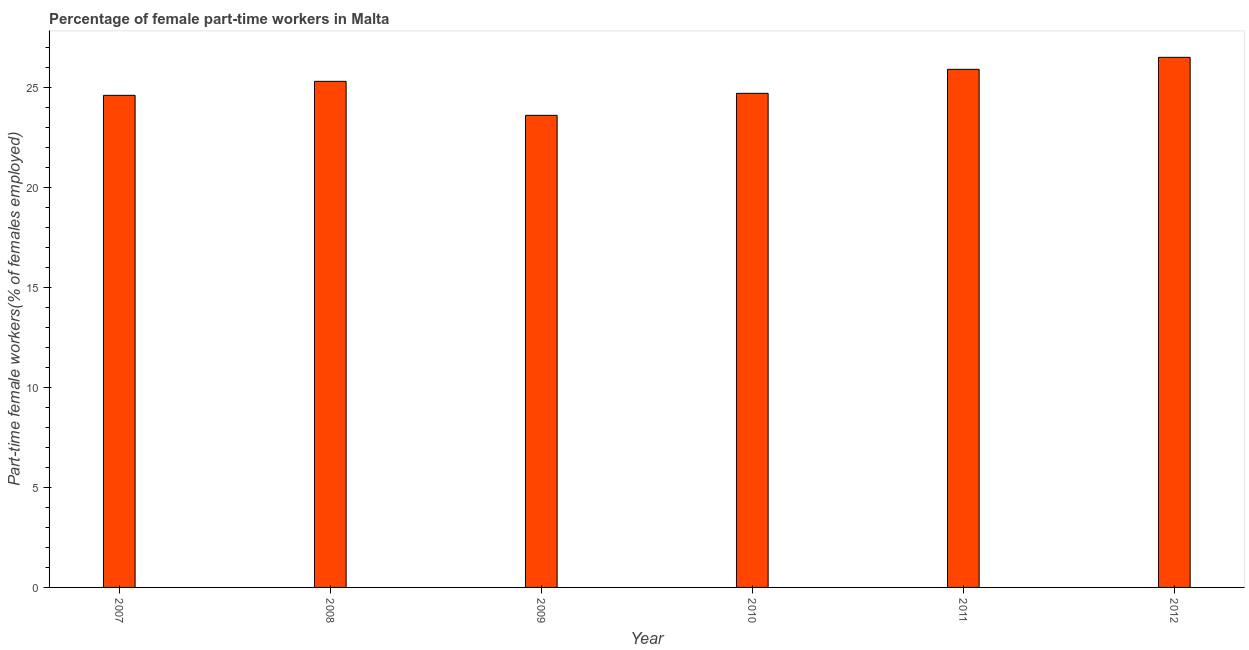What is the title of the graph?
Give a very brief answer. Percentage of female part-time workers in Malta. What is the label or title of the X-axis?
Your answer should be very brief. Year. What is the label or title of the Y-axis?
Keep it short and to the point. Part-time female workers(% of females employed). What is the percentage of part-time female workers in 2009?
Keep it short and to the point. 23.6. Across all years, what is the minimum percentage of part-time female workers?
Your response must be concise. 23.6. In which year was the percentage of part-time female workers maximum?
Make the answer very short. 2012. In which year was the percentage of part-time female workers minimum?
Your answer should be compact. 2009. What is the sum of the percentage of part-time female workers?
Provide a succinct answer. 150.6. What is the average percentage of part-time female workers per year?
Offer a very short reply. 25.1. Do a majority of the years between 2011 and 2010 (inclusive) have percentage of part-time female workers greater than 5 %?
Ensure brevity in your answer.  No. What is the ratio of the percentage of part-time female workers in 2009 to that in 2012?
Make the answer very short. 0.89. What is the difference between the highest and the lowest percentage of part-time female workers?
Your answer should be compact. 2.9. How many bars are there?
Ensure brevity in your answer.  6. Are the values on the major ticks of Y-axis written in scientific E-notation?
Your response must be concise. No. What is the Part-time female workers(% of females employed) of 2007?
Your response must be concise. 24.6. What is the Part-time female workers(% of females employed) in 2008?
Your response must be concise. 25.3. What is the Part-time female workers(% of females employed) in 2009?
Your answer should be very brief. 23.6. What is the Part-time female workers(% of females employed) of 2010?
Your answer should be very brief. 24.7. What is the Part-time female workers(% of females employed) of 2011?
Make the answer very short. 25.9. What is the Part-time female workers(% of females employed) in 2012?
Give a very brief answer. 26.5. What is the difference between the Part-time female workers(% of females employed) in 2007 and 2008?
Ensure brevity in your answer.  -0.7. What is the difference between the Part-time female workers(% of females employed) in 2007 and 2009?
Your response must be concise. 1. What is the difference between the Part-time female workers(% of females employed) in 2007 and 2010?
Give a very brief answer. -0.1. What is the difference between the Part-time female workers(% of females employed) in 2007 and 2011?
Ensure brevity in your answer.  -1.3. What is the difference between the Part-time female workers(% of females employed) in 2008 and 2009?
Provide a succinct answer. 1.7. What is the difference between the Part-time female workers(% of females employed) in 2008 and 2010?
Provide a succinct answer. 0.6. What is the difference between the Part-time female workers(% of females employed) in 2008 and 2012?
Make the answer very short. -1.2. What is the difference between the Part-time female workers(% of females employed) in 2009 and 2010?
Provide a short and direct response. -1.1. What is the difference between the Part-time female workers(% of females employed) in 2011 and 2012?
Give a very brief answer. -0.6. What is the ratio of the Part-time female workers(% of females employed) in 2007 to that in 2009?
Give a very brief answer. 1.04. What is the ratio of the Part-time female workers(% of females employed) in 2007 to that in 2010?
Provide a succinct answer. 1. What is the ratio of the Part-time female workers(% of females employed) in 2007 to that in 2011?
Your answer should be very brief. 0.95. What is the ratio of the Part-time female workers(% of females employed) in 2007 to that in 2012?
Your response must be concise. 0.93. What is the ratio of the Part-time female workers(% of females employed) in 2008 to that in 2009?
Your answer should be compact. 1.07. What is the ratio of the Part-time female workers(% of females employed) in 2008 to that in 2011?
Give a very brief answer. 0.98. What is the ratio of the Part-time female workers(% of females employed) in 2008 to that in 2012?
Your response must be concise. 0.95. What is the ratio of the Part-time female workers(% of females employed) in 2009 to that in 2010?
Ensure brevity in your answer.  0.95. What is the ratio of the Part-time female workers(% of females employed) in 2009 to that in 2011?
Your response must be concise. 0.91. What is the ratio of the Part-time female workers(% of females employed) in 2009 to that in 2012?
Provide a short and direct response. 0.89. What is the ratio of the Part-time female workers(% of females employed) in 2010 to that in 2011?
Provide a succinct answer. 0.95. What is the ratio of the Part-time female workers(% of females employed) in 2010 to that in 2012?
Provide a succinct answer. 0.93. 